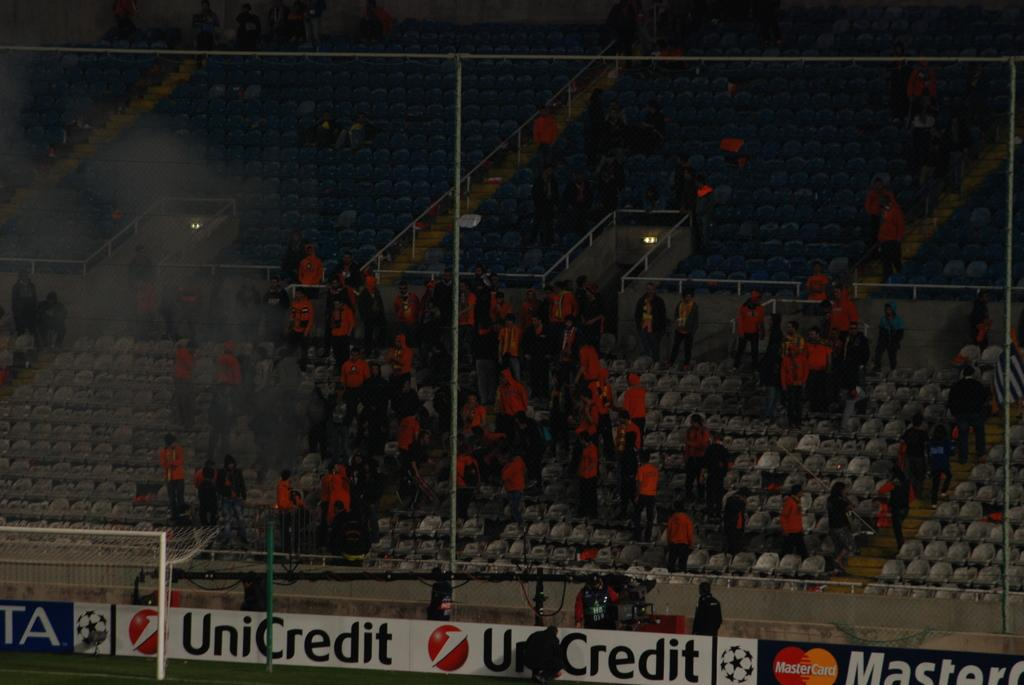<image>
Give a short and clear explanation of the subsequent image. A large crowd in a stadium with a banner that says UniCredit 